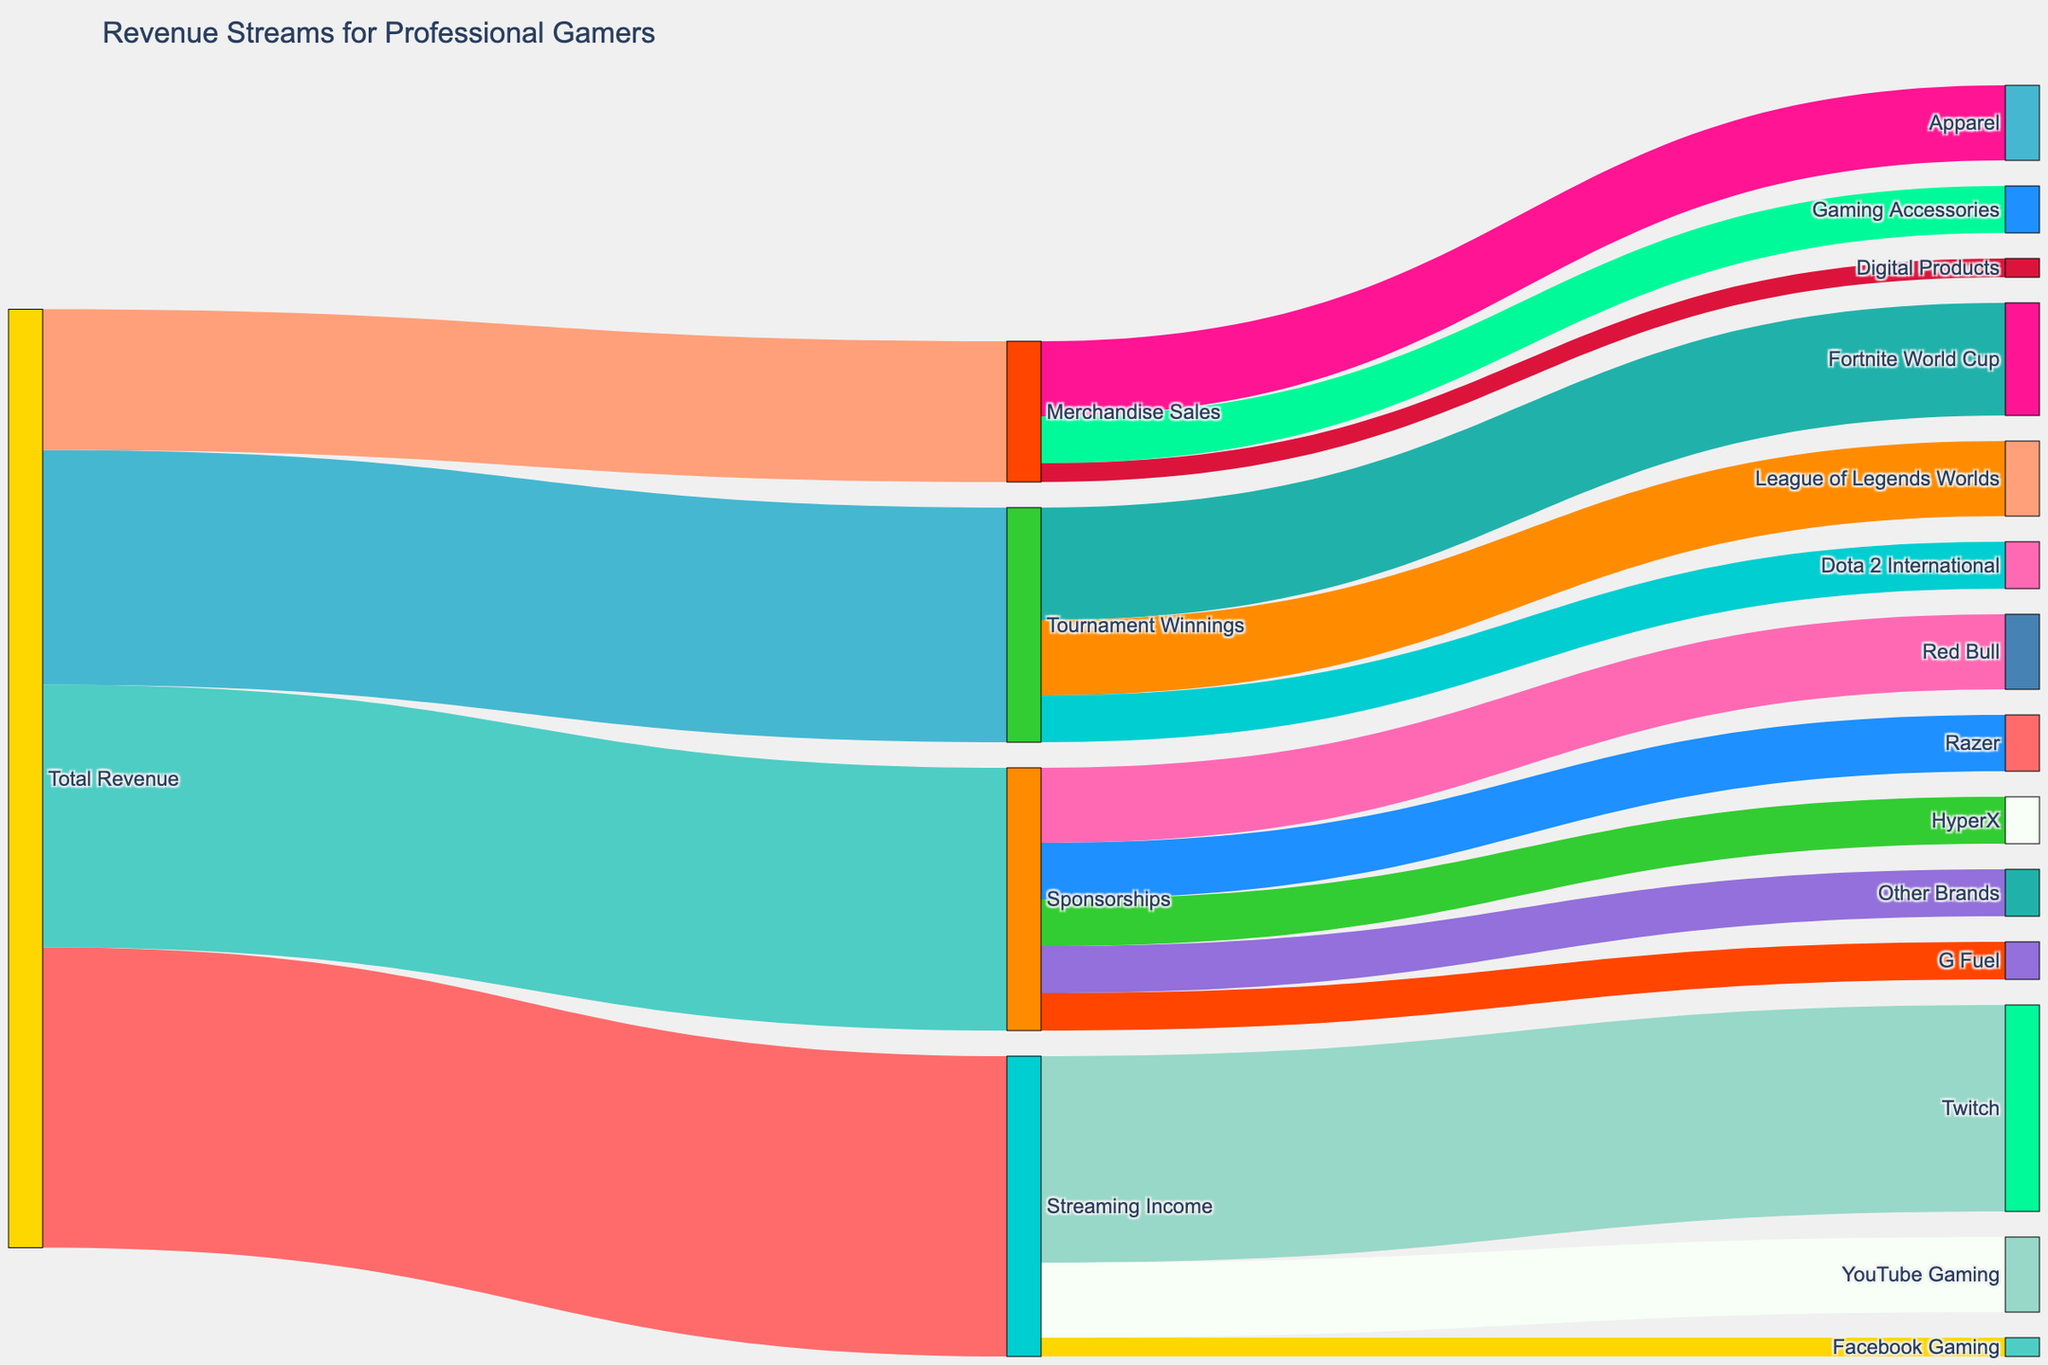What's the total revenue from streaming income? To find the total revenue from streaming income, locate the value associated with "Streaming Income" directly connected to "Total Revenue". The figure shows that "Streaming Income" contributes $3,200,000 to the total revenue.
Answer: $3,200,000 Which streaming platform contributes the most to streaming income? Identify the individual segments under "Streaming Income" and compare their values. Twitch contributes $2,200,000, YouTube Gaming $800,000, and Facebook Gaming $200,000. Twitch has the highest contribution.
Answer: Twitch How much revenue do sponsorships contribute compared to tournament winnings? Find the values associated with "Sponsorships" and "Tournament Winnings" connected to "Total Revenue". Sponsorships contribute $2,800,000 and tournament winnings contribute $2,500,000. Comparing these, sponsorships contribute $300,000 more than tournament winnings.
Answer: $300,000 more What percentage of the total revenue comes from merchandise sales? The revenue from merchandise sales is $1,500,000. Sum up all the revenue streams to find the total revenue, which is $10,000,000. Calculate the percentage: ($1,500,000 / $10,000,000) * 100 = 15%.
Answer: 15% Look at the revenue from individual sponsorship deals. Which brand among Red Bull, Razer, HyperX, and G Fuel provides the least sponsorship revenue? Compare the values for Red Bull ($800,000), Razer ($600,000), HyperX ($500,000), and G Fuel ($400,000). G Fuel provides the least sponsorship revenue.
Answer: G Fuel Distinguish the highest revenue-winning tournament among Fortnite World Cup, League of Legends Worlds, and Dota 2 International. Compare the revenue values of the tournaments: Fortnite World Cup ($1,200,000), League of Legends Worlds ($800,000), and Dota 2 International ($500,000). The Fortnite World Cup has the highest revenue.
Answer: Fortnite World Cup Calculate the combined revenue from YouTube Gaming and Facebook Gaming. Add the revenue from YouTube Gaming ($800,000) and Facebook Gaming ($200,000). The combined revenue is $800,000 + $200,000 = $1,000,000.
Answer: $1,000,000 Which revenue stream among streaming income, sponsorships, tournament winnings, and merchandise sales is smallest? Compare the total revenue values: Streaming Income ($3,200,000), Sponsorships ($2,800,000), Tournament Winnings ($2,500,000), and Merchandise Sales ($1,500,000). Merchandise sales is the smallest revenue stream.
Answer: Merchandise Sales What is the average revenue from all sponsorships? Sum the individual sponsorship revenues: Red Bull ($800,000), Razer ($600,000), HyperX ($500,000), G Fuel ($400,000), and Other Brands ($500,000). Total is ($800,000 + $600,000 + $500,000 + $400,000 + $500,000) = $2,800,000. There are five sponsorships; calculate the average: $2,800,000 / 5 = $560,000.
Answer: $560,000 Among Twitch, YouTube Gaming, and Facebook Gaming, which platform provides the least revenue, and by how much compared to the highest revenue platform? Identify the values for Twitch ($2,200,000), YouTube Gaming ($800,000), and Facebook Gaming ($200,000). Facebook Gaming provides the least revenue, and the difference from the highest revenue platform Twitch is $2,200,000 - $200,000 = $2,000,000.
Answer: Facebook Gaming, $2,000,000 